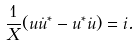<formula> <loc_0><loc_0><loc_500><loc_500>\frac { 1 } { X } ( u \dot { u } ^ { * } - u ^ { * } \dot { u } ) = i .</formula> 